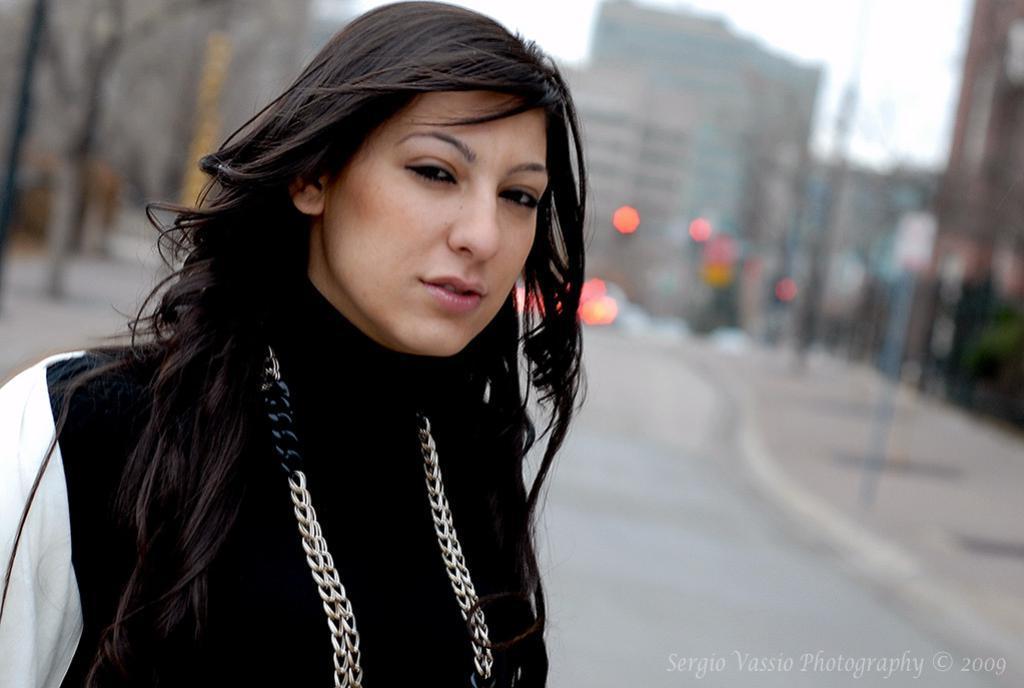Describe this image in one or two sentences. As we can see in the image, in the front there is a women. She is wearing black color dress and there is a road. In the background there are buildings. 